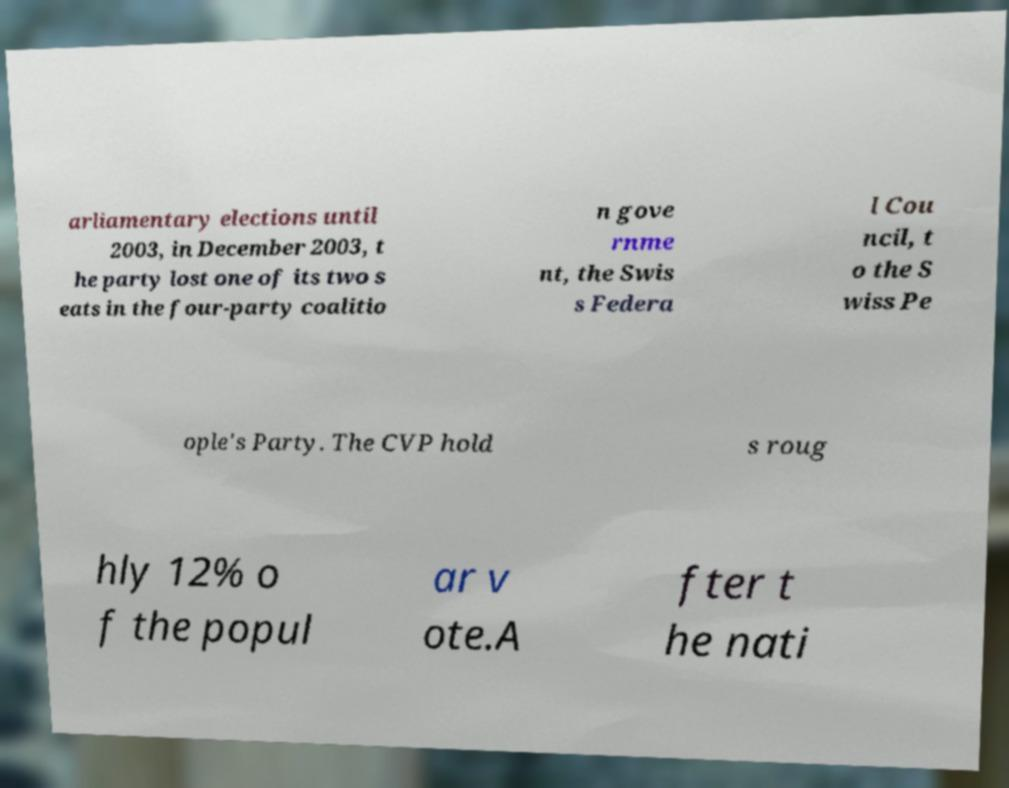What messages or text are displayed in this image? I need them in a readable, typed format. arliamentary elections until 2003, in December 2003, t he party lost one of its two s eats in the four-party coalitio n gove rnme nt, the Swis s Federa l Cou ncil, t o the S wiss Pe ople's Party. The CVP hold s roug hly 12% o f the popul ar v ote.A fter t he nati 